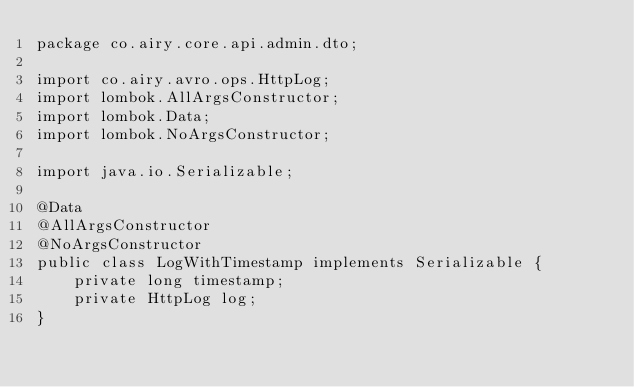<code> <loc_0><loc_0><loc_500><loc_500><_Java_>package co.airy.core.api.admin.dto;

import co.airy.avro.ops.HttpLog;
import lombok.AllArgsConstructor;
import lombok.Data;
import lombok.NoArgsConstructor;

import java.io.Serializable;

@Data
@AllArgsConstructor
@NoArgsConstructor
public class LogWithTimestamp implements Serializable {
    private long timestamp;
    private HttpLog log;
}
</code> 